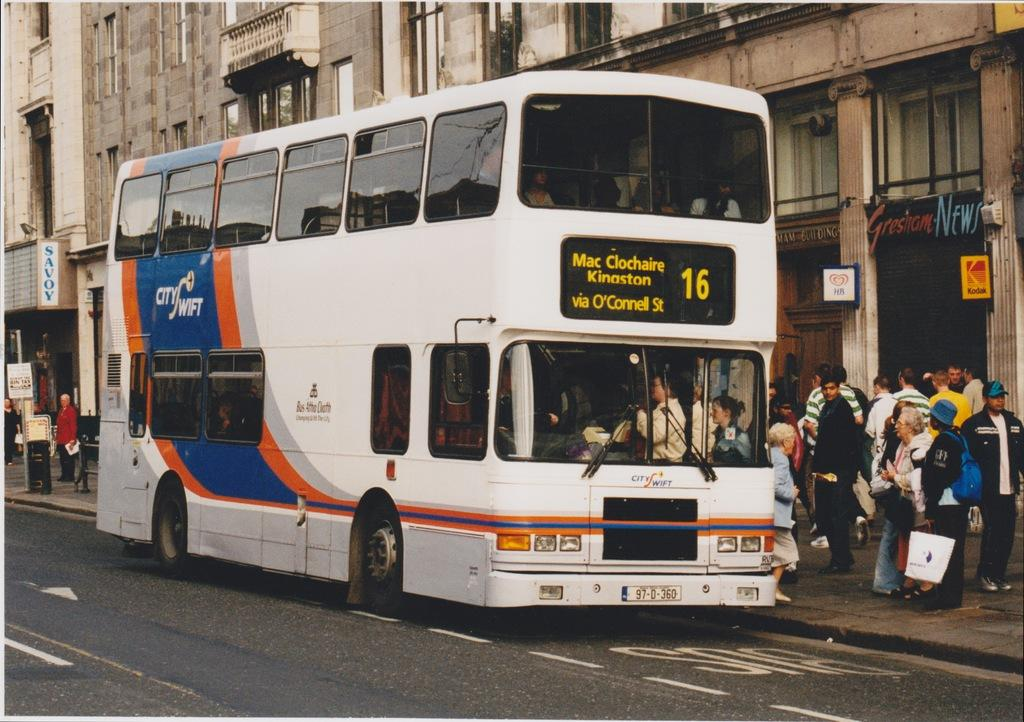What can be seen inside the vehicle in the image? There are people inside the vehicle. What is visible in the background of the image? There are buildings visible in the image. What allows light to enter the vehicle and provides a view of the surroundings? There are windows in the image. What type of signage or advertisement might be present in the image? There are boards present in the image. What is the location of the people on the footpath in relation to the vehicle? There are people on the footpath in the image. What type of stocking is being worn by the people on the train in the image? There is no train present in the image, and therefore no one is wearing stockings. How does the vehicle turn around in the image? The vehicle does not turn around in the image; it is stationary. 